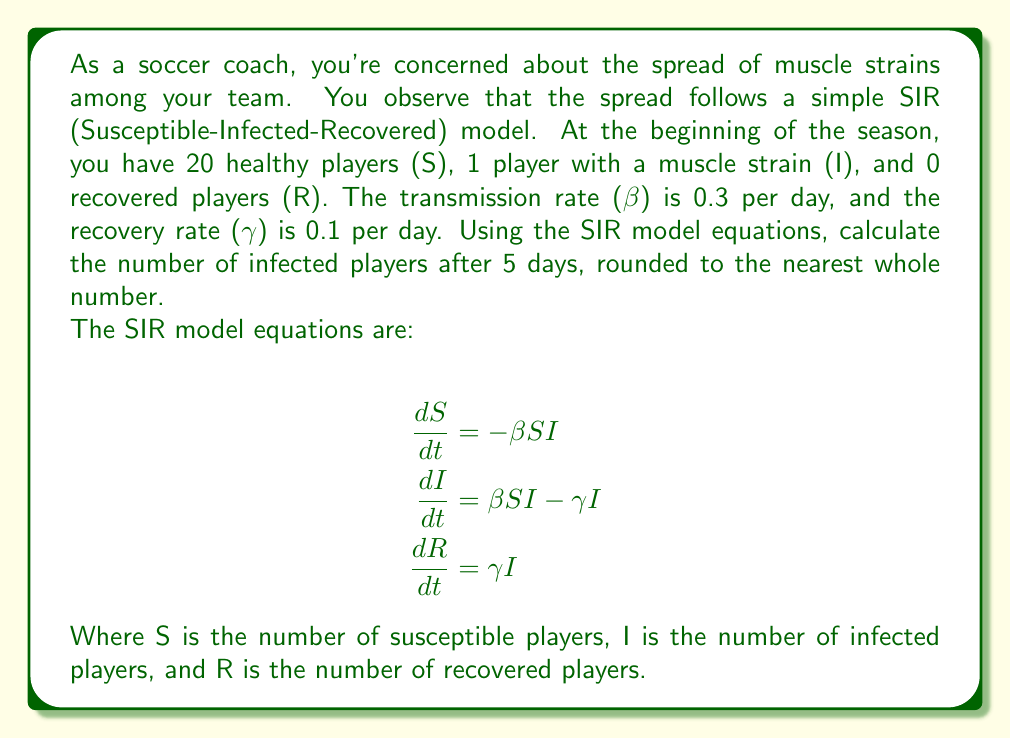Solve this math problem. To solve this problem, we'll use the SIR model equations and apply a simple numerical integration method called Euler's method. We'll calculate the values of S, I, and R for each day over a 5-day period.

Given:
- Initial conditions: S₀ = 20, I₀ = 1, R₀ = 0
- β = 0.3 per day
- γ = 0.1 per day
- Time step: Δt = 1 day
- Number of steps: 5

We'll use the following discretized equations:

$$S_{t+1} = S_t - \beta S_t I_t \Delta t$$
$$I_{t+1} = I_t + (\beta S_t I_t - \gamma I_t) \Delta t$$
$$R_{t+1} = R_t + \gamma I_t \Delta t$$

Let's calculate the values for each day:

Day 0:
S₀ = 20, I₀ = 1, R₀ = 0

Day 1:
S₁ = 20 - 0.3 * 20 * 1 * 1 = 14
I₁ = 1 + (0.3 * 20 * 1 - 0.1 * 1) * 1 = 6.9
R₁ = 0 + 0.1 * 1 * 1 = 0.1

Day 2:
S₂ = 14 - 0.3 * 14 * 6.9 * 1 ≈ 11.1
I₂ = 6.9 + (0.3 * 14 * 6.9 - 0.1 * 6.9) * 1 ≈ 9.7
R₂ = 0.1 + 0.1 * 6.9 * 1 ≈ 0.8

Day 3:
S₃ ≈ 11.1 - 0.3 * 11.1 * 9.7 * 1 ≈ 7.9
I₃ ≈ 9.7 + (0.3 * 11.1 * 9.7 - 0.1 * 9.7) * 1 ≈ 12.0
R₃ ≈ 0.8 + 0.1 * 9.7 * 1 ≈ 1.8

Day 4:
S₄ ≈ 7.9 - 0.3 * 7.9 * 12.0 * 1 ≈ 5.1
I₄ ≈ 12.0 + (0.3 * 7.9 * 12.0 - 0.1 * 12.0) * 1 ≈ 13.4
R₄ ≈ 1.8 + 0.1 * 12.0 * 1 ≈ 3.0

Day 5:
S₅ ≈ 5.1 - 0.3 * 5.1 * 13.4 * 1 ≈ 3.0
I₅ ≈ 13.4 + (0.3 * 5.1 * 13.4 - 0.1 * 13.4) * 1 ≈ 13.8
R₅ ≈ 3.0 + 0.1 * 13.4 * 1 ≈ 4.3

After 5 days, the number of infected players (I₅) is approximately 13.8. Rounding to the nearest whole number, we get 14 infected players.
Answer: 14 infected players 